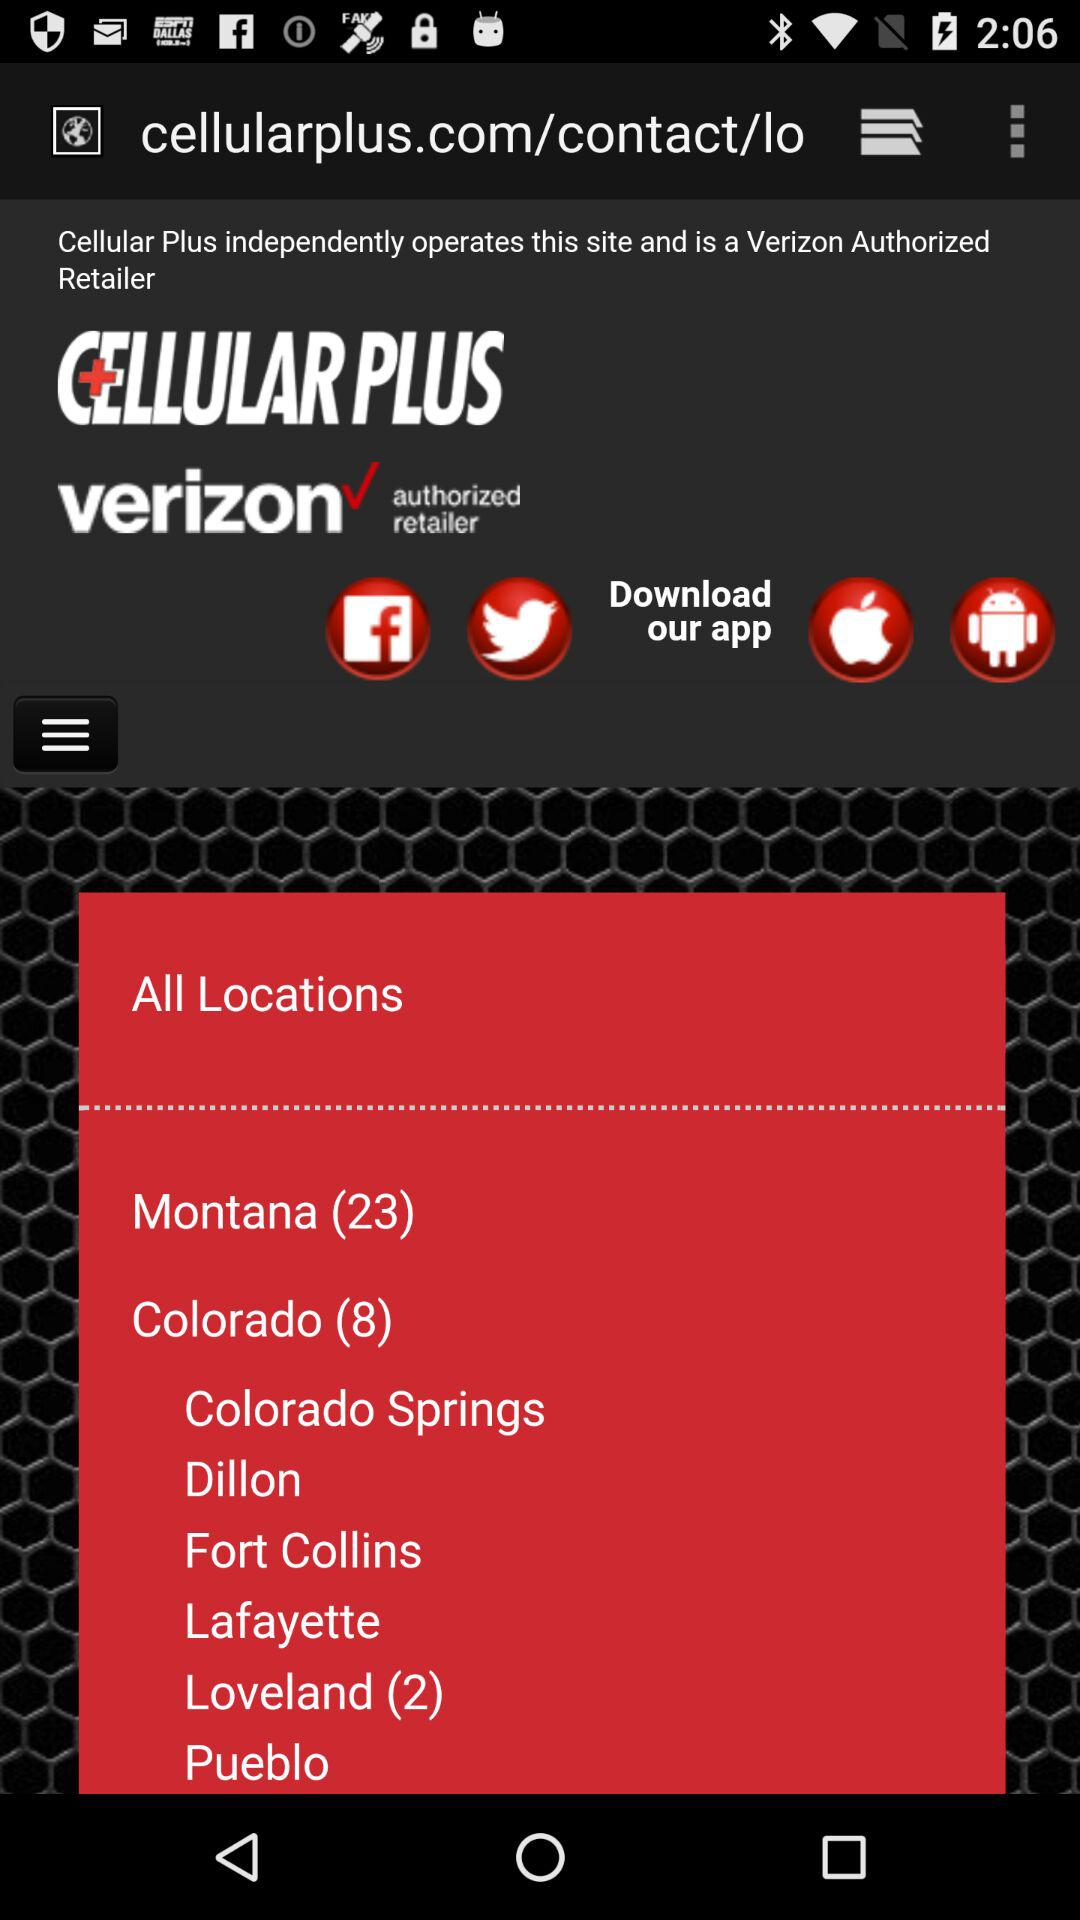What's the total count of Montana? The total count is 23. 